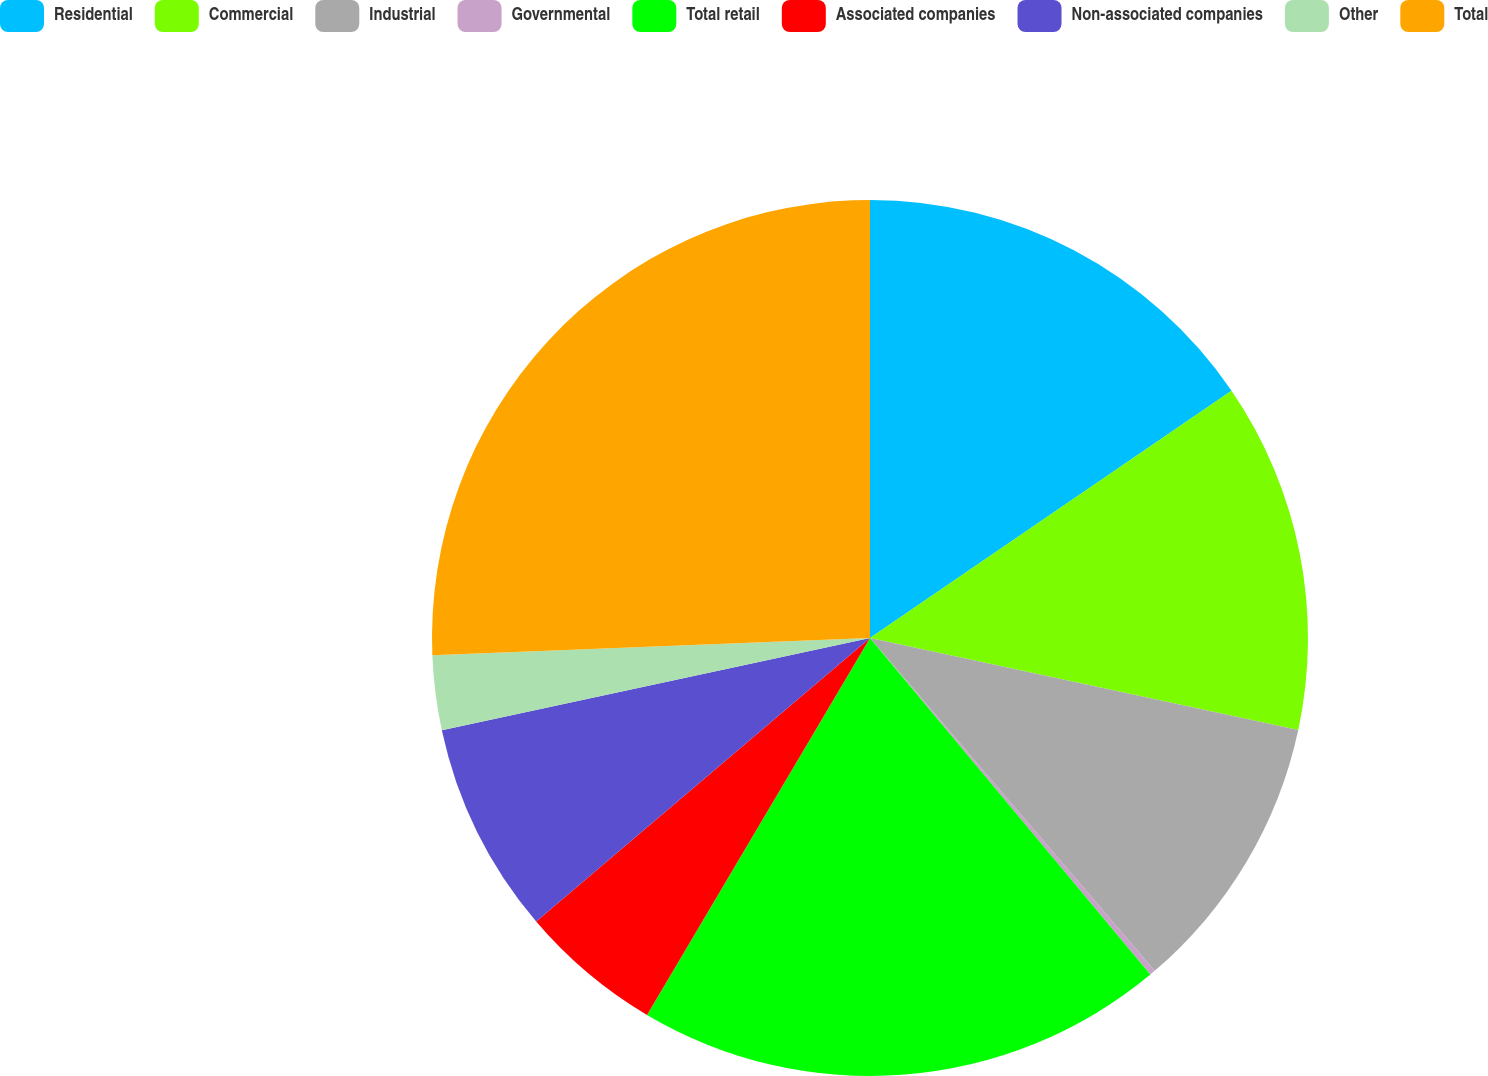<chart> <loc_0><loc_0><loc_500><loc_500><pie_chart><fcel>Residential<fcel>Commercial<fcel>Industrial<fcel>Governmental<fcel>Total retail<fcel>Associated companies<fcel>Non-associated companies<fcel>Other<fcel>Total<nl><fcel>15.45%<fcel>12.91%<fcel>10.37%<fcel>0.21%<fcel>19.55%<fcel>5.29%<fcel>7.83%<fcel>2.75%<fcel>25.62%<nl></chart> 